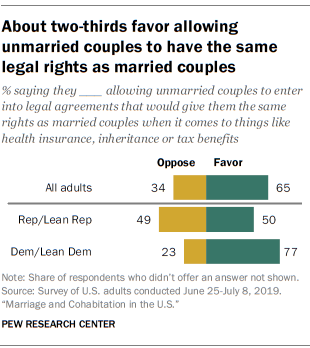Indicate a few pertinent items in this graphic. The difference in value for the 'All adults' bar is 31. The highest value of the yellow bar is 49. 